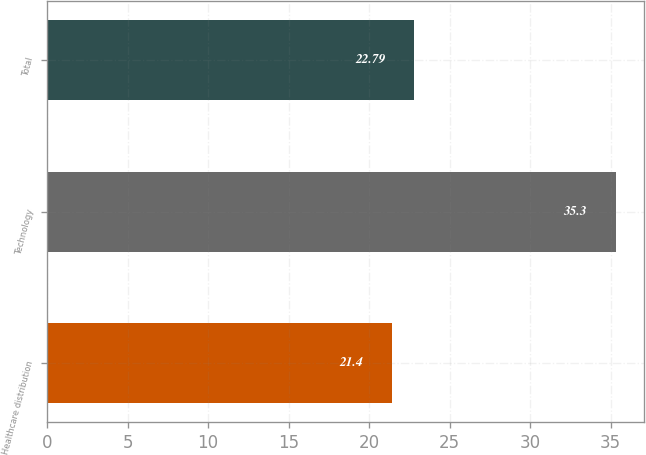Convert chart to OTSL. <chart><loc_0><loc_0><loc_500><loc_500><bar_chart><fcel>Healthcare distribution<fcel>Technology<fcel>Total<nl><fcel>21.4<fcel>35.3<fcel>22.79<nl></chart> 